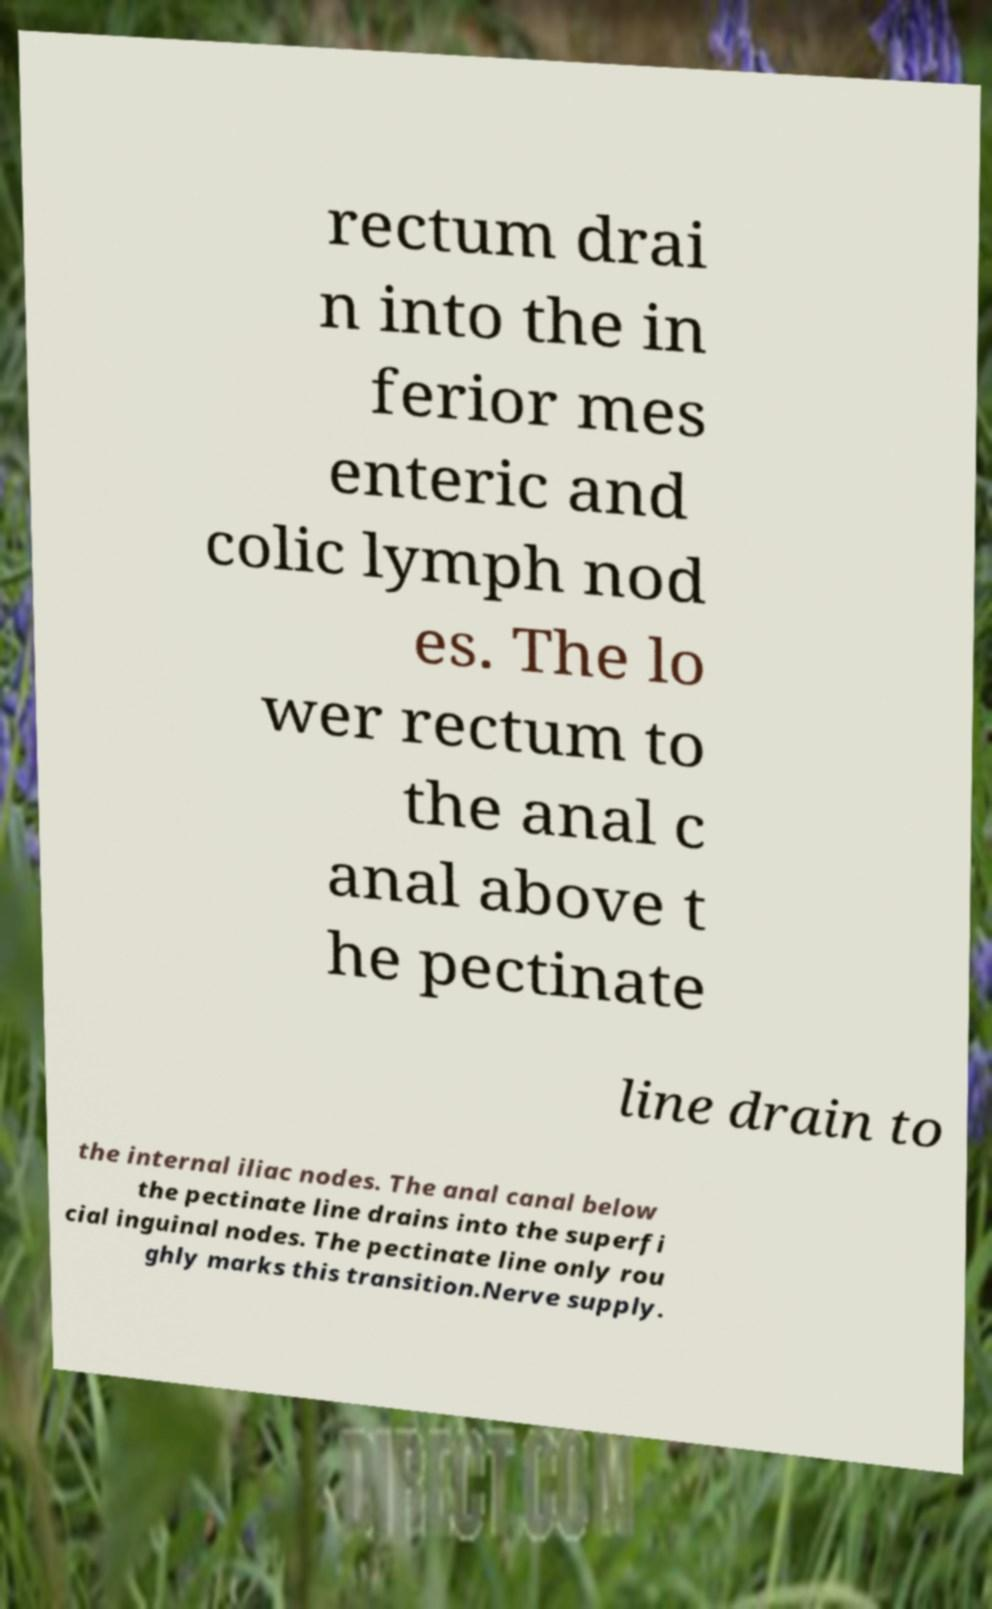Please read and relay the text visible in this image. What does it say? rectum drai n into the in ferior mes enteric and colic lymph nod es. The lo wer rectum to the anal c anal above t he pectinate line drain to the internal iliac nodes. The anal canal below the pectinate line drains into the superfi cial inguinal nodes. The pectinate line only rou ghly marks this transition.Nerve supply. 